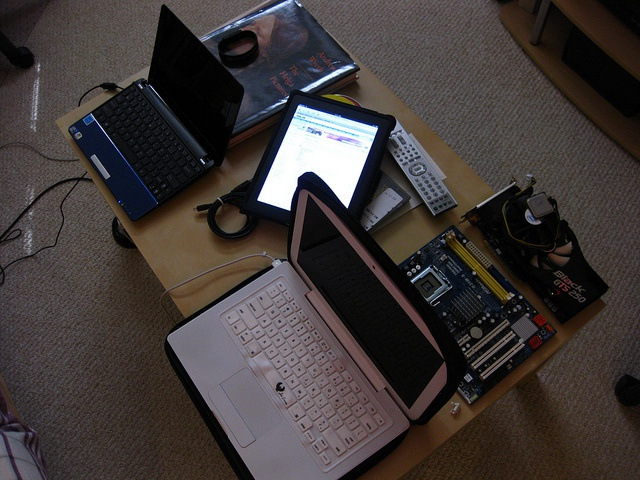Describe the objects in this image and their specific colors. I can see laptop in black and gray tones, laptop in black, navy, gray, and darkblue tones, book in black, gray, and maroon tones, remote in black and gray tones, and mouse in black, gray, and navy tones in this image. 